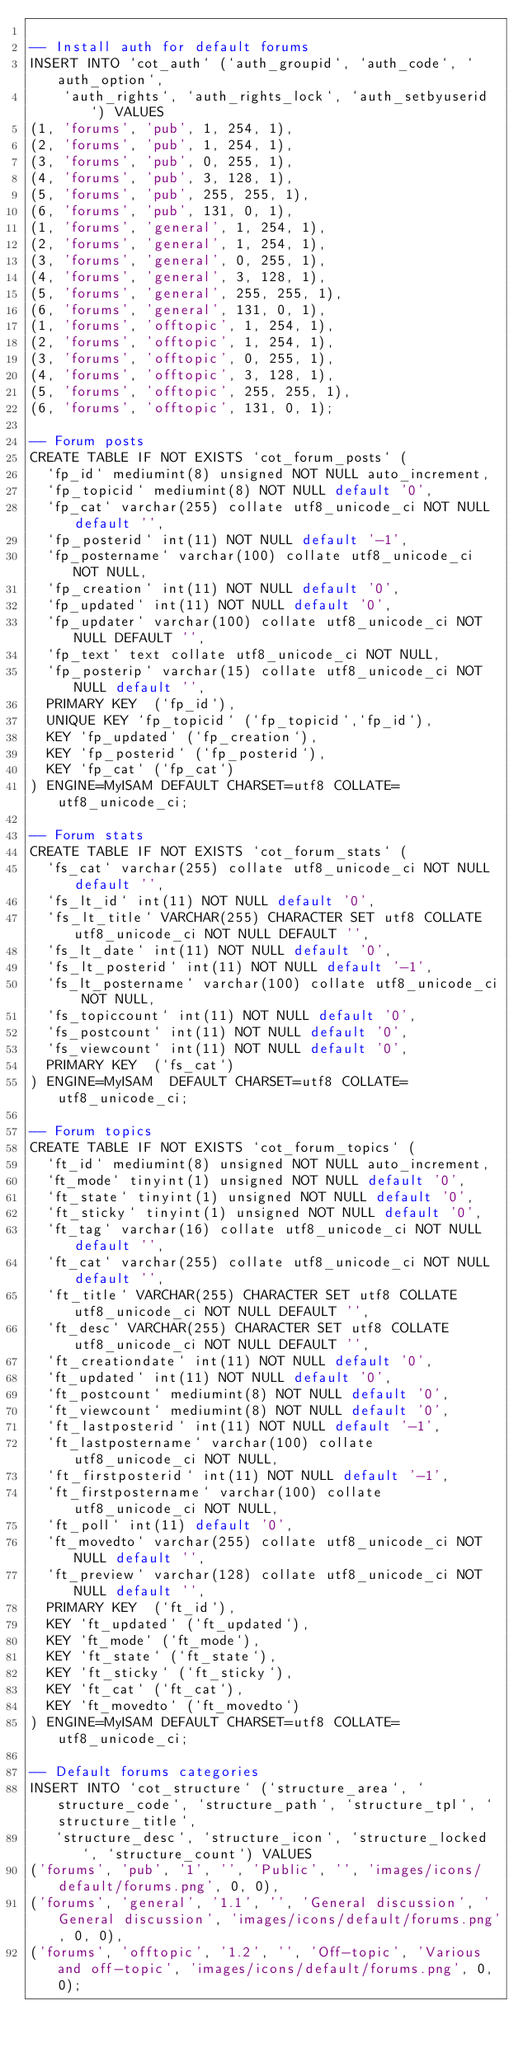Convert code to text. <code><loc_0><loc_0><loc_500><loc_500><_SQL_>
-- Install auth for default forums
INSERT INTO `cot_auth` (`auth_groupid`, `auth_code`, `auth_option`,
	`auth_rights`, `auth_rights_lock`, `auth_setbyuserid`) VALUES
(1, 'forums', 'pub', 1, 254, 1),
(2, 'forums', 'pub', 1, 254, 1),
(3, 'forums', 'pub', 0, 255, 1),
(4, 'forums', 'pub', 3, 128, 1),
(5, 'forums', 'pub', 255, 255, 1),
(6, 'forums', 'pub', 131, 0, 1),
(1, 'forums', 'general', 1, 254, 1),
(2, 'forums', 'general', 1, 254, 1),
(3, 'forums', 'general', 0, 255, 1),
(4, 'forums', 'general', 3, 128, 1),
(5, 'forums', 'general', 255, 255, 1),
(6, 'forums', 'general', 131, 0, 1),
(1, 'forums', 'offtopic', 1, 254, 1),
(2, 'forums', 'offtopic', 1, 254, 1),
(3, 'forums', 'offtopic', 0, 255, 1),
(4, 'forums', 'offtopic', 3, 128, 1),
(5, 'forums', 'offtopic', 255, 255, 1),
(6, 'forums', 'offtopic', 131, 0, 1);

-- Forum posts
CREATE TABLE IF NOT EXISTS `cot_forum_posts` (
  `fp_id` mediumint(8) unsigned NOT NULL auto_increment,
  `fp_topicid` mediumint(8) NOT NULL default '0',
  `fp_cat` varchar(255) collate utf8_unicode_ci NOT NULL default '',
  `fp_posterid` int(11) NOT NULL default '-1',
  `fp_postername` varchar(100) collate utf8_unicode_ci NOT NULL,
  `fp_creation` int(11) NOT NULL default '0',
  `fp_updated` int(11) NOT NULL default '0',
  `fp_updater` varchar(100) collate utf8_unicode_ci NOT NULL DEFAULT '',
  `fp_text` text collate utf8_unicode_ci NOT NULL,
  `fp_posterip` varchar(15) collate utf8_unicode_ci NOT NULL default '',
  PRIMARY KEY  (`fp_id`),
  UNIQUE KEY `fp_topicid` (`fp_topicid`,`fp_id`),
  KEY `fp_updated` (`fp_creation`),
  KEY `fp_posterid` (`fp_posterid`),
  KEY `fp_cat` (`fp_cat`)
) ENGINE=MyISAM DEFAULT CHARSET=utf8 COLLATE=utf8_unicode_ci;

-- Forum stats
CREATE TABLE IF NOT EXISTS `cot_forum_stats` (
  `fs_cat` varchar(255) collate utf8_unicode_ci NOT NULL default '',
  `fs_lt_id` int(11) NOT NULL default '0',
  `fs_lt_title` VARCHAR(255) CHARACTER SET utf8 COLLATE utf8_unicode_ci NOT NULL DEFAULT '',
  `fs_lt_date` int(11) NOT NULL default '0',
  `fs_lt_posterid` int(11) NOT NULL default '-1',
  `fs_lt_postername` varchar(100) collate utf8_unicode_ci NOT NULL,
  `fs_topiccount` int(11) NOT NULL default '0',
  `fs_postcount` int(11) NOT NULL default '0',
  `fs_viewcount` int(11) NOT NULL default '0',
  PRIMARY KEY  (`fs_cat`)
) ENGINE=MyISAM  DEFAULT CHARSET=utf8 COLLATE=utf8_unicode_ci;

-- Forum topics
CREATE TABLE IF NOT EXISTS `cot_forum_topics` (
  `ft_id` mediumint(8) unsigned NOT NULL auto_increment,
  `ft_mode` tinyint(1) unsigned NOT NULL default '0',
  `ft_state` tinyint(1) unsigned NOT NULL default '0',
  `ft_sticky` tinyint(1) unsigned NOT NULL default '0',
  `ft_tag` varchar(16) collate utf8_unicode_ci NOT NULL default '',
  `ft_cat` varchar(255) collate utf8_unicode_ci NOT NULL default '',
  `ft_title` VARCHAR(255) CHARACTER SET utf8 COLLATE utf8_unicode_ci NOT NULL DEFAULT '',
  `ft_desc` VARCHAR(255) CHARACTER SET utf8 COLLATE utf8_unicode_ci NOT NULL DEFAULT '',
  `ft_creationdate` int(11) NOT NULL default '0',
  `ft_updated` int(11) NOT NULL default '0',
  `ft_postcount` mediumint(8) NOT NULL default '0',
  `ft_viewcount` mediumint(8) NOT NULL default '0',
  `ft_lastposterid` int(11) NOT NULL default '-1',
  `ft_lastpostername` varchar(100) collate utf8_unicode_ci NOT NULL,
  `ft_firstposterid` int(11) NOT NULL default '-1',
  `ft_firstpostername` varchar(100) collate utf8_unicode_ci NOT NULL,
  `ft_poll` int(11) default '0',
  `ft_movedto` varchar(255) collate utf8_unicode_ci NOT NULL default '',
  `ft_preview` varchar(128) collate utf8_unicode_ci NOT NULL default '',
  PRIMARY KEY  (`ft_id`),
  KEY `ft_updated` (`ft_updated`),
  KEY `ft_mode` (`ft_mode`),
  KEY `ft_state` (`ft_state`),
  KEY `ft_sticky` (`ft_sticky`),
  KEY `ft_cat` (`ft_cat`),
  KEY `ft_movedto` (`ft_movedto`)
) ENGINE=MyISAM DEFAULT CHARSET=utf8 COLLATE=utf8_unicode_ci;

-- Default forums categories
INSERT INTO `cot_structure` (`structure_area`, `structure_code`, `structure_path`, `structure_tpl`, `structure_title`,
   `structure_desc`, `structure_icon`, `structure_locked`, `structure_count`) VALUES
('forums', 'pub', '1', '', 'Public', '', 'images/icons/default/forums.png', 0, 0),
('forums', 'general', '1.1', '', 'General discussion', 'General discussion', 'images/icons/default/forums.png', 0, 0),
('forums', 'offtopic', '1.2', '', 'Off-topic', 'Various and off-topic', 'images/icons/default/forums.png', 0, 0);</code> 